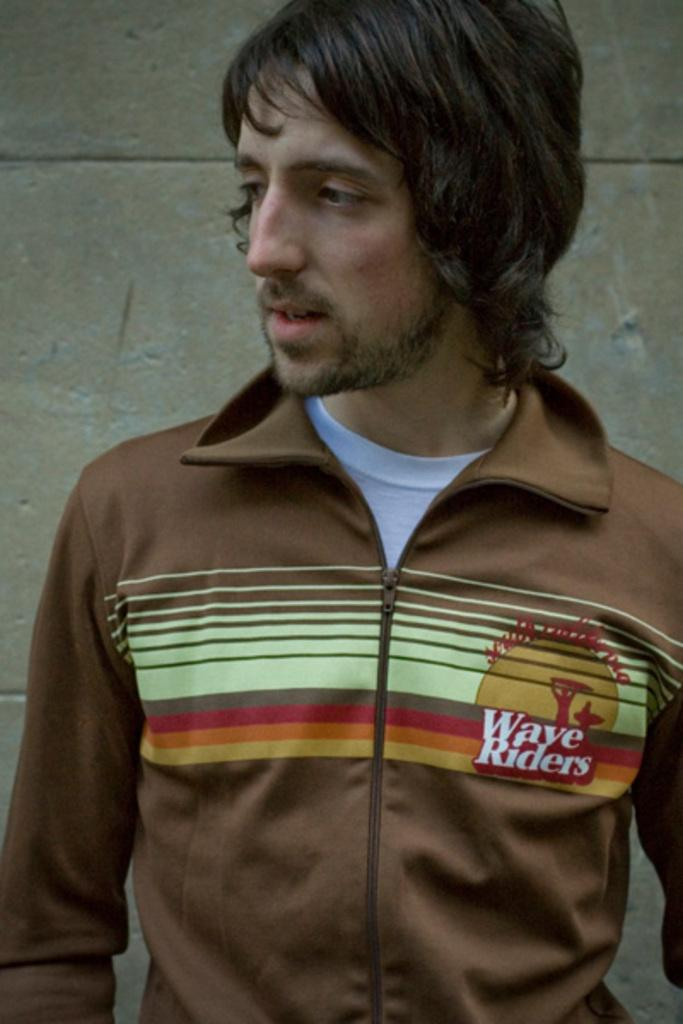What is present in the image? There is a man in the image. Can you describe what the man is wearing? The man is wearing a jacket. What can be seen in the background of the image? There is a wall in the background of the image. What type of tin can be seen in the man's hand in the image? There is no tin present in the man's hand or anywhere in the image. 